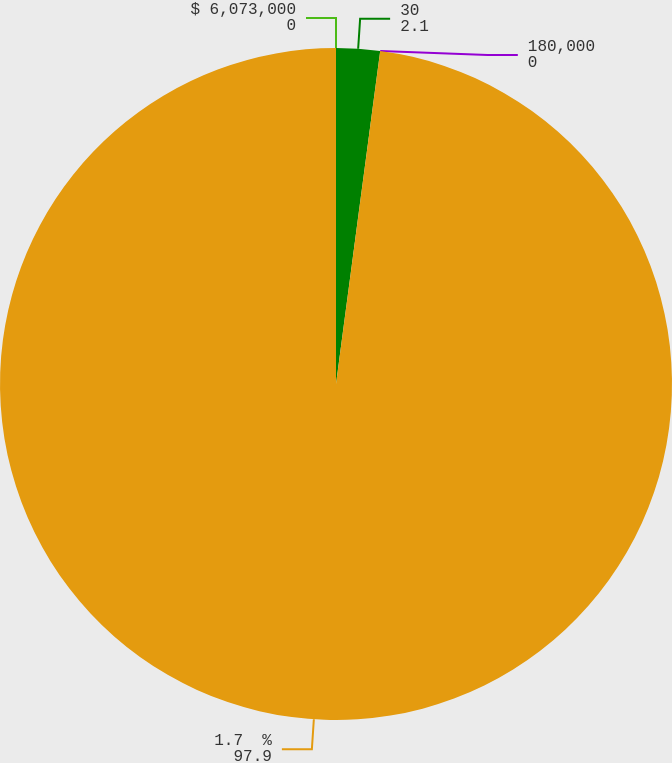Convert chart to OTSL. <chart><loc_0><loc_0><loc_500><loc_500><pie_chart><fcel>$ 6,073,000<fcel>30<fcel>180,000<fcel>1.7  %<nl><fcel>0.0%<fcel>2.1%<fcel>0.0%<fcel>97.9%<nl></chart> 